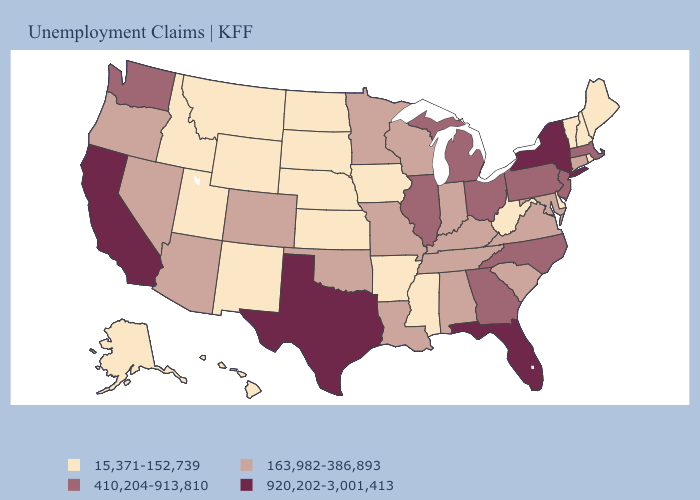Does the first symbol in the legend represent the smallest category?
Be succinct. Yes. Among the states that border Arizona , does Nevada have the highest value?
Quick response, please. No. What is the value of Hawaii?
Quick response, please. 15,371-152,739. What is the value of Vermont?
Write a very short answer. 15,371-152,739. Name the states that have a value in the range 163,982-386,893?
Quick response, please. Alabama, Arizona, Colorado, Connecticut, Indiana, Kentucky, Louisiana, Maryland, Minnesota, Missouri, Nevada, Oklahoma, Oregon, South Carolina, Tennessee, Virginia, Wisconsin. Among the states that border Arkansas , which have the lowest value?
Keep it brief. Mississippi. Does Arizona have a higher value than Nevada?
Concise answer only. No. What is the value of Oklahoma?
Give a very brief answer. 163,982-386,893. What is the value of South Dakota?
Keep it brief. 15,371-152,739. What is the highest value in the Northeast ?
Give a very brief answer. 920,202-3,001,413. Name the states that have a value in the range 410,204-913,810?
Quick response, please. Georgia, Illinois, Massachusetts, Michigan, New Jersey, North Carolina, Ohio, Pennsylvania, Washington. Name the states that have a value in the range 920,202-3,001,413?
Give a very brief answer. California, Florida, New York, Texas. Name the states that have a value in the range 15,371-152,739?
Answer briefly. Alaska, Arkansas, Delaware, Hawaii, Idaho, Iowa, Kansas, Maine, Mississippi, Montana, Nebraska, New Hampshire, New Mexico, North Dakota, Rhode Island, South Dakota, Utah, Vermont, West Virginia, Wyoming. What is the value of California?
Short answer required. 920,202-3,001,413. Name the states that have a value in the range 15,371-152,739?
Answer briefly. Alaska, Arkansas, Delaware, Hawaii, Idaho, Iowa, Kansas, Maine, Mississippi, Montana, Nebraska, New Hampshire, New Mexico, North Dakota, Rhode Island, South Dakota, Utah, Vermont, West Virginia, Wyoming. 